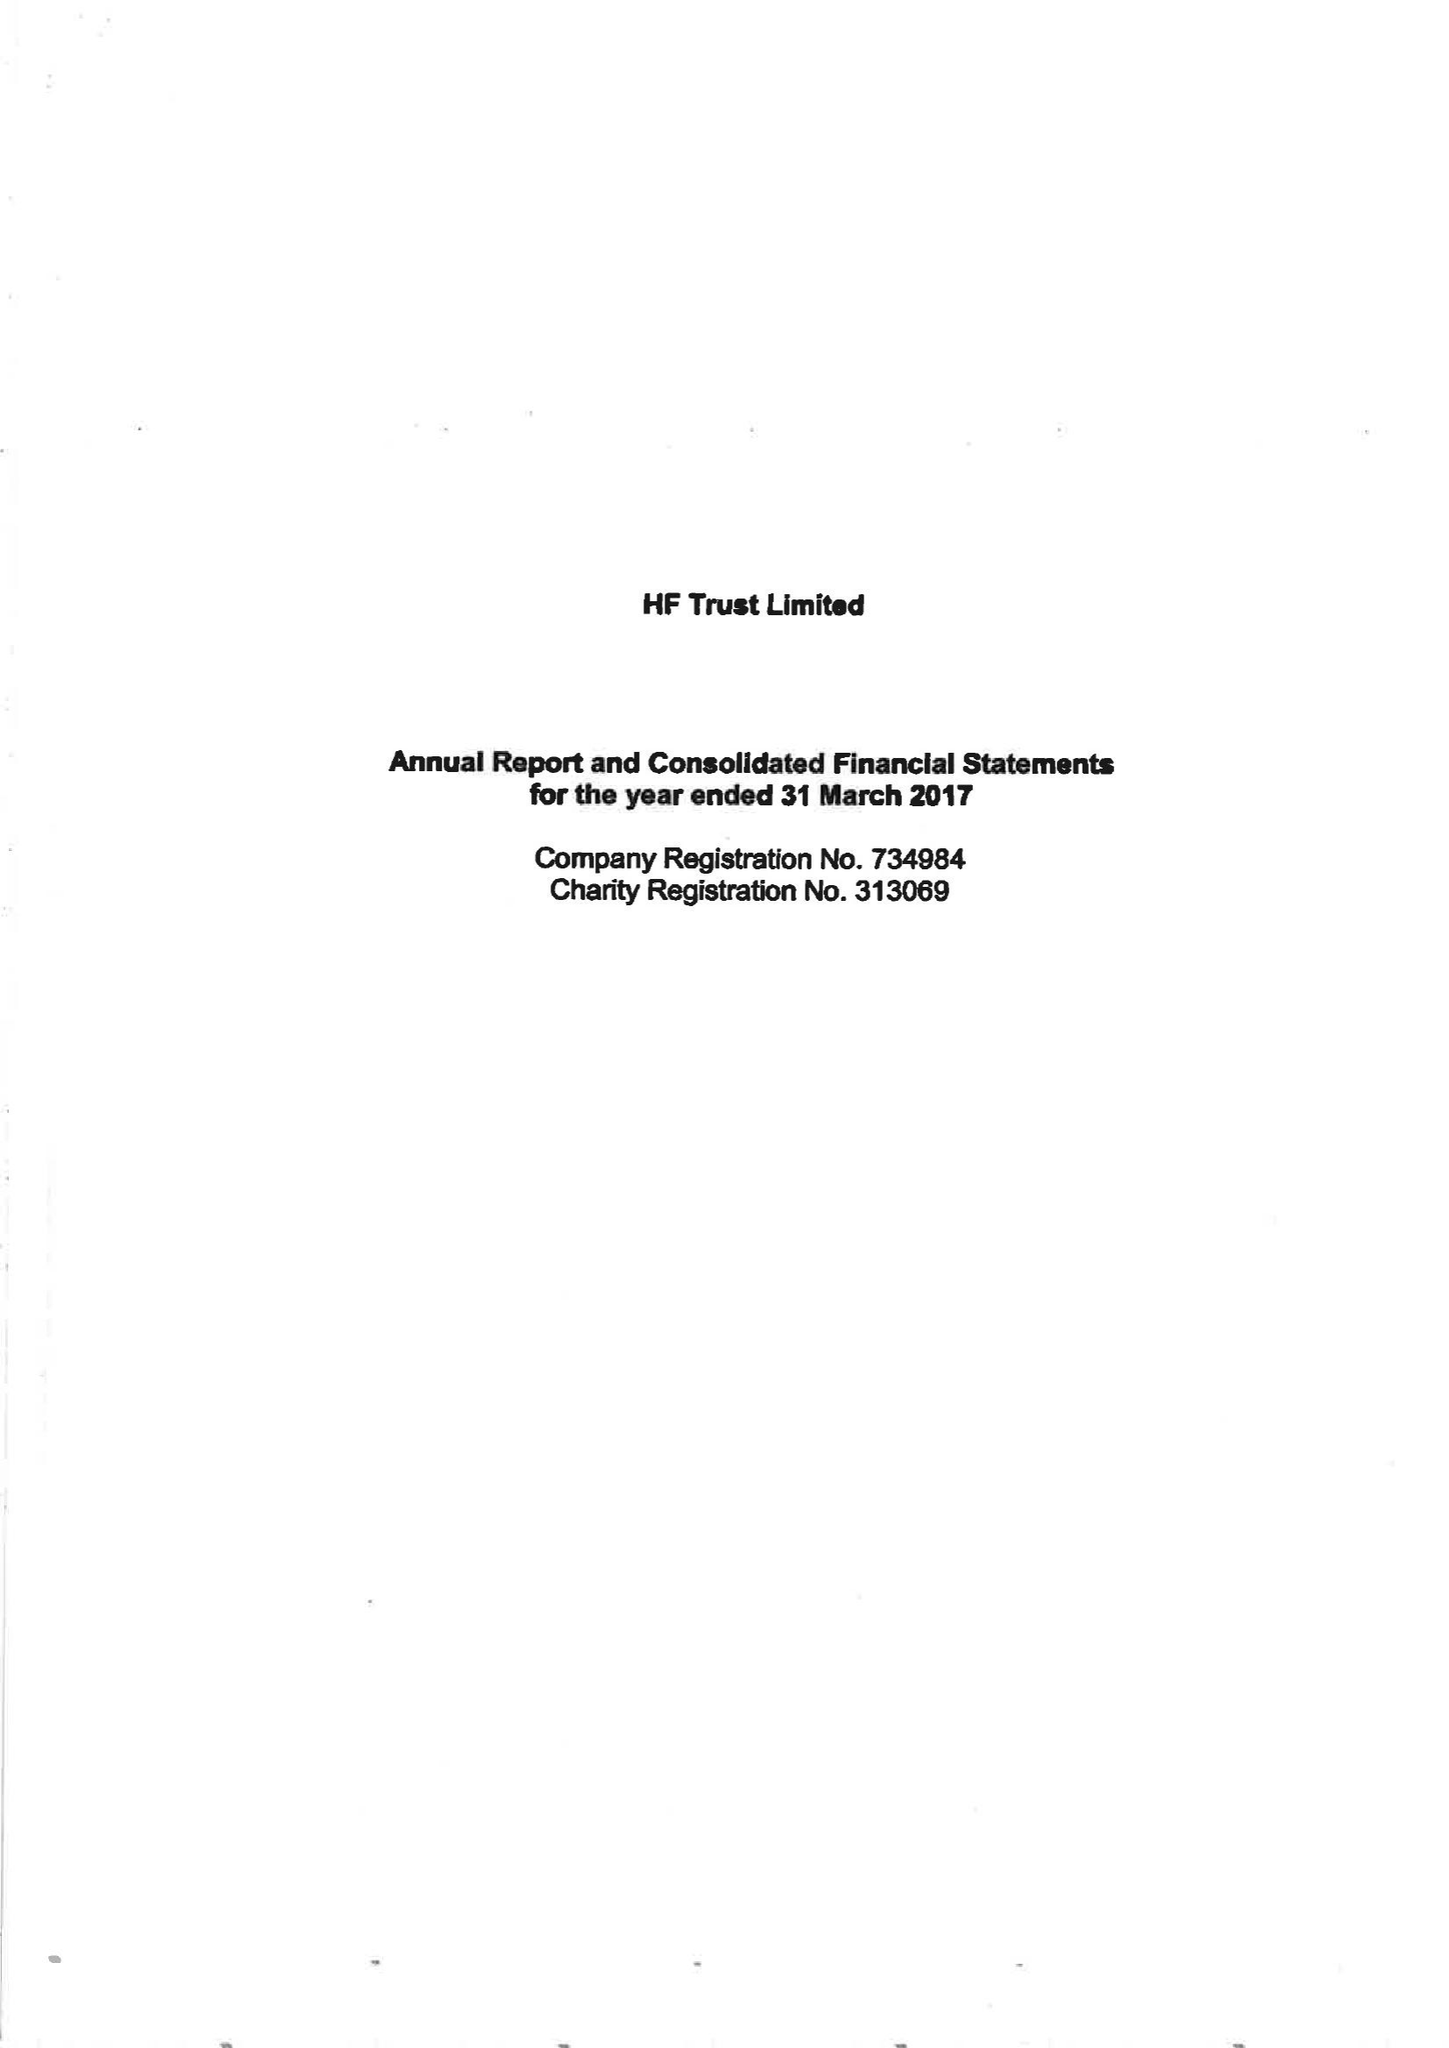What is the value for the charity_number?
Answer the question using a single word or phrase. 313069 